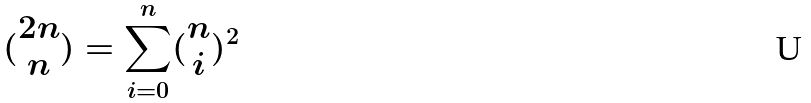<formula> <loc_0><loc_0><loc_500><loc_500>( \begin{matrix} 2 n \\ n \end{matrix} ) = \sum _ { i = 0 } ^ { n } ( \begin{matrix} n \\ i \end{matrix} ) ^ { 2 }</formula> 